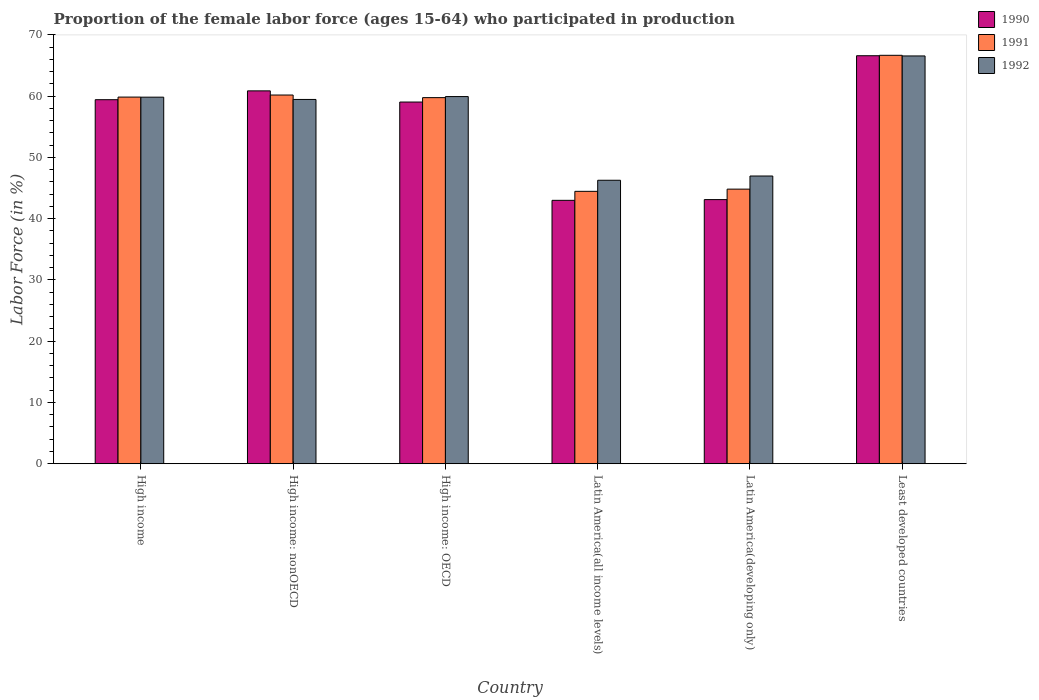How many different coloured bars are there?
Offer a very short reply. 3. How many groups of bars are there?
Give a very brief answer. 6. Are the number of bars per tick equal to the number of legend labels?
Ensure brevity in your answer.  Yes. Are the number of bars on each tick of the X-axis equal?
Your answer should be very brief. Yes. How many bars are there on the 1st tick from the left?
Ensure brevity in your answer.  3. How many bars are there on the 4th tick from the right?
Your answer should be very brief. 3. What is the label of the 5th group of bars from the left?
Keep it short and to the point. Latin America(developing only). What is the proportion of the female labor force who participated in production in 1991 in Least developed countries?
Keep it short and to the point. 66.68. Across all countries, what is the maximum proportion of the female labor force who participated in production in 1990?
Ensure brevity in your answer.  66.61. Across all countries, what is the minimum proportion of the female labor force who participated in production in 1990?
Your answer should be very brief. 43. In which country was the proportion of the female labor force who participated in production in 1990 maximum?
Ensure brevity in your answer.  Least developed countries. In which country was the proportion of the female labor force who participated in production in 1992 minimum?
Give a very brief answer. Latin America(all income levels). What is the total proportion of the female labor force who participated in production in 1991 in the graph?
Keep it short and to the point. 335.79. What is the difference between the proportion of the female labor force who participated in production in 1990 in High income and that in Latin America(all income levels)?
Ensure brevity in your answer.  16.43. What is the difference between the proportion of the female labor force who participated in production in 1990 in High income: OECD and the proportion of the female labor force who participated in production in 1992 in Least developed countries?
Offer a terse response. -7.52. What is the average proportion of the female labor force who participated in production in 1992 per country?
Give a very brief answer. 56.51. What is the difference between the proportion of the female labor force who participated in production of/in 1990 and proportion of the female labor force who participated in production of/in 1991 in Latin America(all income levels)?
Give a very brief answer. -1.47. In how many countries, is the proportion of the female labor force who participated in production in 1990 greater than 68 %?
Provide a succinct answer. 0. What is the ratio of the proportion of the female labor force who participated in production in 1992 in High income: nonOECD to that in Latin America(all income levels)?
Make the answer very short. 1.29. What is the difference between the highest and the second highest proportion of the female labor force who participated in production in 1991?
Keep it short and to the point. 6.82. What is the difference between the highest and the lowest proportion of the female labor force who participated in production in 1991?
Provide a succinct answer. 22.21. Is the sum of the proportion of the female labor force who participated in production in 1990 in High income: OECD and Least developed countries greater than the maximum proportion of the female labor force who participated in production in 1992 across all countries?
Your answer should be very brief. Yes. What does the 2nd bar from the right in High income: OECD represents?
Ensure brevity in your answer.  1991. Is it the case that in every country, the sum of the proportion of the female labor force who participated in production in 1990 and proportion of the female labor force who participated in production in 1991 is greater than the proportion of the female labor force who participated in production in 1992?
Provide a short and direct response. Yes. Are all the bars in the graph horizontal?
Provide a short and direct response. No. Does the graph contain grids?
Give a very brief answer. No. Where does the legend appear in the graph?
Provide a succinct answer. Top right. What is the title of the graph?
Offer a very short reply. Proportion of the female labor force (ages 15-64) who participated in production. Does "1996" appear as one of the legend labels in the graph?
Ensure brevity in your answer.  No. What is the label or title of the X-axis?
Offer a terse response. Country. What is the label or title of the Y-axis?
Provide a short and direct response. Labor Force (in %). What is the Labor Force (in %) in 1990 in High income?
Give a very brief answer. 59.43. What is the Labor Force (in %) in 1991 in High income?
Make the answer very short. 59.86. What is the Labor Force (in %) in 1992 in High income?
Your answer should be very brief. 59.84. What is the Labor Force (in %) in 1990 in High income: nonOECD?
Make the answer very short. 60.87. What is the Labor Force (in %) in 1991 in High income: nonOECD?
Your response must be concise. 60.19. What is the Labor Force (in %) of 1992 in High income: nonOECD?
Your answer should be compact. 59.47. What is the Labor Force (in %) of 1990 in High income: OECD?
Offer a terse response. 59.05. What is the Labor Force (in %) in 1991 in High income: OECD?
Provide a short and direct response. 59.77. What is the Labor Force (in %) in 1992 in High income: OECD?
Give a very brief answer. 59.94. What is the Labor Force (in %) of 1990 in Latin America(all income levels)?
Your answer should be compact. 43. What is the Labor Force (in %) of 1991 in Latin America(all income levels)?
Provide a short and direct response. 44.47. What is the Labor Force (in %) of 1992 in Latin America(all income levels)?
Keep it short and to the point. 46.28. What is the Labor Force (in %) of 1990 in Latin America(developing only)?
Ensure brevity in your answer.  43.12. What is the Labor Force (in %) in 1991 in Latin America(developing only)?
Provide a succinct answer. 44.83. What is the Labor Force (in %) of 1992 in Latin America(developing only)?
Provide a succinct answer. 46.97. What is the Labor Force (in %) of 1990 in Least developed countries?
Offer a very short reply. 66.61. What is the Labor Force (in %) in 1991 in Least developed countries?
Your answer should be very brief. 66.68. What is the Labor Force (in %) in 1992 in Least developed countries?
Provide a short and direct response. 66.57. Across all countries, what is the maximum Labor Force (in %) in 1990?
Make the answer very short. 66.61. Across all countries, what is the maximum Labor Force (in %) in 1991?
Give a very brief answer. 66.68. Across all countries, what is the maximum Labor Force (in %) of 1992?
Provide a short and direct response. 66.57. Across all countries, what is the minimum Labor Force (in %) of 1990?
Provide a succinct answer. 43. Across all countries, what is the minimum Labor Force (in %) of 1991?
Give a very brief answer. 44.47. Across all countries, what is the minimum Labor Force (in %) of 1992?
Provide a short and direct response. 46.28. What is the total Labor Force (in %) in 1990 in the graph?
Offer a terse response. 332.08. What is the total Labor Force (in %) in 1991 in the graph?
Your answer should be very brief. 335.79. What is the total Labor Force (in %) in 1992 in the graph?
Your answer should be very brief. 339.07. What is the difference between the Labor Force (in %) in 1990 in High income and that in High income: nonOECD?
Your response must be concise. -1.44. What is the difference between the Labor Force (in %) of 1991 in High income and that in High income: nonOECD?
Your answer should be compact. -0.34. What is the difference between the Labor Force (in %) in 1992 in High income and that in High income: nonOECD?
Keep it short and to the point. 0.37. What is the difference between the Labor Force (in %) in 1990 in High income and that in High income: OECD?
Your answer should be very brief. 0.38. What is the difference between the Labor Force (in %) of 1991 in High income and that in High income: OECD?
Your response must be concise. 0.09. What is the difference between the Labor Force (in %) in 1992 in High income and that in High income: OECD?
Make the answer very short. -0.1. What is the difference between the Labor Force (in %) in 1990 in High income and that in Latin America(all income levels)?
Ensure brevity in your answer.  16.43. What is the difference between the Labor Force (in %) of 1991 in High income and that in Latin America(all income levels)?
Offer a terse response. 15.39. What is the difference between the Labor Force (in %) in 1992 in High income and that in Latin America(all income levels)?
Your response must be concise. 13.56. What is the difference between the Labor Force (in %) in 1990 in High income and that in Latin America(developing only)?
Your answer should be compact. 16.31. What is the difference between the Labor Force (in %) in 1991 in High income and that in Latin America(developing only)?
Keep it short and to the point. 15.03. What is the difference between the Labor Force (in %) of 1992 in High income and that in Latin America(developing only)?
Your answer should be very brief. 12.87. What is the difference between the Labor Force (in %) of 1990 in High income and that in Least developed countries?
Offer a terse response. -7.18. What is the difference between the Labor Force (in %) of 1991 in High income and that in Least developed countries?
Provide a short and direct response. -6.82. What is the difference between the Labor Force (in %) in 1992 in High income and that in Least developed countries?
Keep it short and to the point. -6.73. What is the difference between the Labor Force (in %) in 1990 in High income: nonOECD and that in High income: OECD?
Provide a short and direct response. 1.82. What is the difference between the Labor Force (in %) of 1991 in High income: nonOECD and that in High income: OECD?
Offer a terse response. 0.43. What is the difference between the Labor Force (in %) of 1992 in High income: nonOECD and that in High income: OECD?
Provide a short and direct response. -0.47. What is the difference between the Labor Force (in %) of 1990 in High income: nonOECD and that in Latin America(all income levels)?
Your response must be concise. 17.87. What is the difference between the Labor Force (in %) of 1991 in High income: nonOECD and that in Latin America(all income levels)?
Provide a short and direct response. 15.72. What is the difference between the Labor Force (in %) in 1992 in High income: nonOECD and that in Latin America(all income levels)?
Your answer should be compact. 13.19. What is the difference between the Labor Force (in %) of 1990 in High income: nonOECD and that in Latin America(developing only)?
Your response must be concise. 17.75. What is the difference between the Labor Force (in %) in 1991 in High income: nonOECD and that in Latin America(developing only)?
Your answer should be compact. 15.36. What is the difference between the Labor Force (in %) of 1992 in High income: nonOECD and that in Latin America(developing only)?
Ensure brevity in your answer.  12.5. What is the difference between the Labor Force (in %) in 1990 in High income: nonOECD and that in Least developed countries?
Keep it short and to the point. -5.74. What is the difference between the Labor Force (in %) in 1991 in High income: nonOECD and that in Least developed countries?
Your response must be concise. -6.48. What is the difference between the Labor Force (in %) of 1992 in High income: nonOECD and that in Least developed countries?
Provide a succinct answer. -7.1. What is the difference between the Labor Force (in %) in 1990 in High income: OECD and that in Latin America(all income levels)?
Offer a terse response. 16.05. What is the difference between the Labor Force (in %) of 1991 in High income: OECD and that in Latin America(all income levels)?
Make the answer very short. 15.3. What is the difference between the Labor Force (in %) of 1992 in High income: OECD and that in Latin America(all income levels)?
Your response must be concise. 13.66. What is the difference between the Labor Force (in %) of 1990 in High income: OECD and that in Latin America(developing only)?
Keep it short and to the point. 15.93. What is the difference between the Labor Force (in %) in 1991 in High income: OECD and that in Latin America(developing only)?
Provide a succinct answer. 14.94. What is the difference between the Labor Force (in %) of 1992 in High income: OECD and that in Latin America(developing only)?
Give a very brief answer. 12.97. What is the difference between the Labor Force (in %) in 1990 in High income: OECD and that in Least developed countries?
Ensure brevity in your answer.  -7.56. What is the difference between the Labor Force (in %) of 1991 in High income: OECD and that in Least developed countries?
Ensure brevity in your answer.  -6.91. What is the difference between the Labor Force (in %) in 1992 in High income: OECD and that in Least developed countries?
Provide a succinct answer. -6.63. What is the difference between the Labor Force (in %) in 1990 in Latin America(all income levels) and that in Latin America(developing only)?
Provide a short and direct response. -0.12. What is the difference between the Labor Force (in %) in 1991 in Latin America(all income levels) and that in Latin America(developing only)?
Your answer should be compact. -0.36. What is the difference between the Labor Force (in %) of 1992 in Latin America(all income levels) and that in Latin America(developing only)?
Your answer should be compact. -0.69. What is the difference between the Labor Force (in %) of 1990 in Latin America(all income levels) and that in Least developed countries?
Your answer should be compact. -23.61. What is the difference between the Labor Force (in %) of 1991 in Latin America(all income levels) and that in Least developed countries?
Provide a succinct answer. -22.21. What is the difference between the Labor Force (in %) of 1992 in Latin America(all income levels) and that in Least developed countries?
Ensure brevity in your answer.  -20.29. What is the difference between the Labor Force (in %) in 1990 in Latin America(developing only) and that in Least developed countries?
Offer a very short reply. -23.49. What is the difference between the Labor Force (in %) of 1991 in Latin America(developing only) and that in Least developed countries?
Keep it short and to the point. -21.85. What is the difference between the Labor Force (in %) in 1992 in Latin America(developing only) and that in Least developed countries?
Your response must be concise. -19.6. What is the difference between the Labor Force (in %) in 1990 in High income and the Labor Force (in %) in 1991 in High income: nonOECD?
Offer a very short reply. -0.76. What is the difference between the Labor Force (in %) of 1990 in High income and the Labor Force (in %) of 1992 in High income: nonOECD?
Offer a terse response. -0.04. What is the difference between the Labor Force (in %) in 1991 in High income and the Labor Force (in %) in 1992 in High income: nonOECD?
Provide a succinct answer. 0.38. What is the difference between the Labor Force (in %) in 1990 in High income and the Labor Force (in %) in 1991 in High income: OECD?
Provide a succinct answer. -0.34. What is the difference between the Labor Force (in %) of 1990 in High income and the Labor Force (in %) of 1992 in High income: OECD?
Ensure brevity in your answer.  -0.51. What is the difference between the Labor Force (in %) in 1991 in High income and the Labor Force (in %) in 1992 in High income: OECD?
Offer a terse response. -0.08. What is the difference between the Labor Force (in %) in 1990 in High income and the Labor Force (in %) in 1991 in Latin America(all income levels)?
Provide a short and direct response. 14.96. What is the difference between the Labor Force (in %) of 1990 in High income and the Labor Force (in %) of 1992 in Latin America(all income levels)?
Your answer should be very brief. 13.15. What is the difference between the Labor Force (in %) of 1991 in High income and the Labor Force (in %) of 1992 in Latin America(all income levels)?
Provide a short and direct response. 13.58. What is the difference between the Labor Force (in %) of 1990 in High income and the Labor Force (in %) of 1991 in Latin America(developing only)?
Offer a very short reply. 14.6. What is the difference between the Labor Force (in %) in 1990 in High income and the Labor Force (in %) in 1992 in Latin America(developing only)?
Provide a short and direct response. 12.46. What is the difference between the Labor Force (in %) of 1991 in High income and the Labor Force (in %) of 1992 in Latin America(developing only)?
Your answer should be very brief. 12.88. What is the difference between the Labor Force (in %) of 1990 in High income and the Labor Force (in %) of 1991 in Least developed countries?
Offer a terse response. -7.25. What is the difference between the Labor Force (in %) in 1990 in High income and the Labor Force (in %) in 1992 in Least developed countries?
Offer a very short reply. -7.14. What is the difference between the Labor Force (in %) of 1991 in High income and the Labor Force (in %) of 1992 in Least developed countries?
Ensure brevity in your answer.  -6.72. What is the difference between the Labor Force (in %) of 1990 in High income: nonOECD and the Labor Force (in %) of 1991 in High income: OECD?
Provide a short and direct response. 1.11. What is the difference between the Labor Force (in %) in 1990 in High income: nonOECD and the Labor Force (in %) in 1992 in High income: OECD?
Give a very brief answer. 0.93. What is the difference between the Labor Force (in %) in 1991 in High income: nonOECD and the Labor Force (in %) in 1992 in High income: OECD?
Keep it short and to the point. 0.25. What is the difference between the Labor Force (in %) of 1990 in High income: nonOECD and the Labor Force (in %) of 1991 in Latin America(all income levels)?
Ensure brevity in your answer.  16.4. What is the difference between the Labor Force (in %) of 1990 in High income: nonOECD and the Labor Force (in %) of 1992 in Latin America(all income levels)?
Your response must be concise. 14.59. What is the difference between the Labor Force (in %) in 1991 in High income: nonOECD and the Labor Force (in %) in 1992 in Latin America(all income levels)?
Your answer should be very brief. 13.92. What is the difference between the Labor Force (in %) in 1990 in High income: nonOECD and the Labor Force (in %) in 1991 in Latin America(developing only)?
Offer a very short reply. 16.04. What is the difference between the Labor Force (in %) in 1990 in High income: nonOECD and the Labor Force (in %) in 1992 in Latin America(developing only)?
Provide a short and direct response. 13.9. What is the difference between the Labor Force (in %) in 1991 in High income: nonOECD and the Labor Force (in %) in 1992 in Latin America(developing only)?
Make the answer very short. 13.22. What is the difference between the Labor Force (in %) in 1990 in High income: nonOECD and the Labor Force (in %) in 1991 in Least developed countries?
Provide a short and direct response. -5.81. What is the difference between the Labor Force (in %) of 1990 in High income: nonOECD and the Labor Force (in %) of 1992 in Least developed countries?
Provide a succinct answer. -5.7. What is the difference between the Labor Force (in %) in 1991 in High income: nonOECD and the Labor Force (in %) in 1992 in Least developed countries?
Keep it short and to the point. -6.38. What is the difference between the Labor Force (in %) of 1990 in High income: OECD and the Labor Force (in %) of 1991 in Latin America(all income levels)?
Offer a very short reply. 14.58. What is the difference between the Labor Force (in %) of 1990 in High income: OECD and the Labor Force (in %) of 1992 in Latin America(all income levels)?
Give a very brief answer. 12.77. What is the difference between the Labor Force (in %) of 1991 in High income: OECD and the Labor Force (in %) of 1992 in Latin America(all income levels)?
Offer a very short reply. 13.49. What is the difference between the Labor Force (in %) of 1990 in High income: OECD and the Labor Force (in %) of 1991 in Latin America(developing only)?
Offer a very short reply. 14.22. What is the difference between the Labor Force (in %) in 1990 in High income: OECD and the Labor Force (in %) in 1992 in Latin America(developing only)?
Provide a short and direct response. 12.08. What is the difference between the Labor Force (in %) of 1991 in High income: OECD and the Labor Force (in %) of 1992 in Latin America(developing only)?
Give a very brief answer. 12.79. What is the difference between the Labor Force (in %) in 1990 in High income: OECD and the Labor Force (in %) in 1991 in Least developed countries?
Give a very brief answer. -7.63. What is the difference between the Labor Force (in %) of 1990 in High income: OECD and the Labor Force (in %) of 1992 in Least developed countries?
Provide a succinct answer. -7.52. What is the difference between the Labor Force (in %) in 1991 in High income: OECD and the Labor Force (in %) in 1992 in Least developed countries?
Make the answer very short. -6.81. What is the difference between the Labor Force (in %) of 1990 in Latin America(all income levels) and the Labor Force (in %) of 1991 in Latin America(developing only)?
Offer a very short reply. -1.83. What is the difference between the Labor Force (in %) in 1990 in Latin America(all income levels) and the Labor Force (in %) in 1992 in Latin America(developing only)?
Offer a terse response. -3.97. What is the difference between the Labor Force (in %) of 1991 in Latin America(all income levels) and the Labor Force (in %) of 1992 in Latin America(developing only)?
Offer a very short reply. -2.5. What is the difference between the Labor Force (in %) in 1990 in Latin America(all income levels) and the Labor Force (in %) in 1991 in Least developed countries?
Offer a very short reply. -23.68. What is the difference between the Labor Force (in %) of 1990 in Latin America(all income levels) and the Labor Force (in %) of 1992 in Least developed countries?
Provide a short and direct response. -23.57. What is the difference between the Labor Force (in %) of 1991 in Latin America(all income levels) and the Labor Force (in %) of 1992 in Least developed countries?
Your answer should be very brief. -22.1. What is the difference between the Labor Force (in %) of 1990 in Latin America(developing only) and the Labor Force (in %) of 1991 in Least developed countries?
Give a very brief answer. -23.56. What is the difference between the Labor Force (in %) of 1990 in Latin America(developing only) and the Labor Force (in %) of 1992 in Least developed countries?
Ensure brevity in your answer.  -23.45. What is the difference between the Labor Force (in %) in 1991 in Latin America(developing only) and the Labor Force (in %) in 1992 in Least developed countries?
Offer a terse response. -21.74. What is the average Labor Force (in %) of 1990 per country?
Your answer should be compact. 55.35. What is the average Labor Force (in %) in 1991 per country?
Give a very brief answer. 55.97. What is the average Labor Force (in %) in 1992 per country?
Your response must be concise. 56.51. What is the difference between the Labor Force (in %) of 1990 and Labor Force (in %) of 1991 in High income?
Provide a short and direct response. -0.43. What is the difference between the Labor Force (in %) of 1990 and Labor Force (in %) of 1992 in High income?
Your answer should be compact. -0.41. What is the difference between the Labor Force (in %) in 1991 and Labor Force (in %) in 1992 in High income?
Provide a succinct answer. 0.01. What is the difference between the Labor Force (in %) of 1990 and Labor Force (in %) of 1991 in High income: nonOECD?
Your answer should be compact. 0.68. What is the difference between the Labor Force (in %) in 1990 and Labor Force (in %) in 1992 in High income: nonOECD?
Offer a terse response. 1.4. What is the difference between the Labor Force (in %) of 1991 and Labor Force (in %) of 1992 in High income: nonOECD?
Offer a terse response. 0.72. What is the difference between the Labor Force (in %) of 1990 and Labor Force (in %) of 1991 in High income: OECD?
Your answer should be very brief. -0.72. What is the difference between the Labor Force (in %) of 1990 and Labor Force (in %) of 1992 in High income: OECD?
Keep it short and to the point. -0.89. What is the difference between the Labor Force (in %) of 1991 and Labor Force (in %) of 1992 in High income: OECD?
Keep it short and to the point. -0.17. What is the difference between the Labor Force (in %) in 1990 and Labor Force (in %) in 1991 in Latin America(all income levels)?
Offer a very short reply. -1.47. What is the difference between the Labor Force (in %) in 1990 and Labor Force (in %) in 1992 in Latin America(all income levels)?
Ensure brevity in your answer.  -3.28. What is the difference between the Labor Force (in %) of 1991 and Labor Force (in %) of 1992 in Latin America(all income levels)?
Offer a terse response. -1.81. What is the difference between the Labor Force (in %) in 1990 and Labor Force (in %) in 1991 in Latin America(developing only)?
Your answer should be very brief. -1.71. What is the difference between the Labor Force (in %) in 1990 and Labor Force (in %) in 1992 in Latin America(developing only)?
Offer a terse response. -3.85. What is the difference between the Labor Force (in %) of 1991 and Labor Force (in %) of 1992 in Latin America(developing only)?
Your answer should be very brief. -2.14. What is the difference between the Labor Force (in %) of 1990 and Labor Force (in %) of 1991 in Least developed countries?
Give a very brief answer. -0.07. What is the difference between the Labor Force (in %) of 1990 and Labor Force (in %) of 1992 in Least developed countries?
Your answer should be compact. 0.03. What is the difference between the Labor Force (in %) of 1991 and Labor Force (in %) of 1992 in Least developed countries?
Provide a short and direct response. 0.1. What is the ratio of the Labor Force (in %) in 1990 in High income to that in High income: nonOECD?
Offer a terse response. 0.98. What is the ratio of the Labor Force (in %) of 1992 in High income to that in High income: nonOECD?
Provide a short and direct response. 1.01. What is the ratio of the Labor Force (in %) of 1991 in High income to that in High income: OECD?
Offer a terse response. 1. What is the ratio of the Labor Force (in %) of 1990 in High income to that in Latin America(all income levels)?
Your answer should be very brief. 1.38. What is the ratio of the Labor Force (in %) in 1991 in High income to that in Latin America(all income levels)?
Offer a very short reply. 1.35. What is the ratio of the Labor Force (in %) in 1992 in High income to that in Latin America(all income levels)?
Give a very brief answer. 1.29. What is the ratio of the Labor Force (in %) of 1990 in High income to that in Latin America(developing only)?
Keep it short and to the point. 1.38. What is the ratio of the Labor Force (in %) in 1991 in High income to that in Latin America(developing only)?
Provide a short and direct response. 1.34. What is the ratio of the Labor Force (in %) of 1992 in High income to that in Latin America(developing only)?
Give a very brief answer. 1.27. What is the ratio of the Labor Force (in %) in 1990 in High income to that in Least developed countries?
Your answer should be compact. 0.89. What is the ratio of the Labor Force (in %) in 1991 in High income to that in Least developed countries?
Give a very brief answer. 0.9. What is the ratio of the Labor Force (in %) in 1992 in High income to that in Least developed countries?
Provide a short and direct response. 0.9. What is the ratio of the Labor Force (in %) of 1990 in High income: nonOECD to that in High income: OECD?
Make the answer very short. 1.03. What is the ratio of the Labor Force (in %) of 1991 in High income: nonOECD to that in High income: OECD?
Offer a very short reply. 1.01. What is the ratio of the Labor Force (in %) in 1992 in High income: nonOECD to that in High income: OECD?
Give a very brief answer. 0.99. What is the ratio of the Labor Force (in %) in 1990 in High income: nonOECD to that in Latin America(all income levels)?
Make the answer very short. 1.42. What is the ratio of the Labor Force (in %) in 1991 in High income: nonOECD to that in Latin America(all income levels)?
Offer a terse response. 1.35. What is the ratio of the Labor Force (in %) of 1992 in High income: nonOECD to that in Latin America(all income levels)?
Your answer should be very brief. 1.29. What is the ratio of the Labor Force (in %) in 1990 in High income: nonOECD to that in Latin America(developing only)?
Ensure brevity in your answer.  1.41. What is the ratio of the Labor Force (in %) of 1991 in High income: nonOECD to that in Latin America(developing only)?
Give a very brief answer. 1.34. What is the ratio of the Labor Force (in %) in 1992 in High income: nonOECD to that in Latin America(developing only)?
Ensure brevity in your answer.  1.27. What is the ratio of the Labor Force (in %) of 1990 in High income: nonOECD to that in Least developed countries?
Make the answer very short. 0.91. What is the ratio of the Labor Force (in %) of 1991 in High income: nonOECD to that in Least developed countries?
Your response must be concise. 0.9. What is the ratio of the Labor Force (in %) of 1992 in High income: nonOECD to that in Least developed countries?
Your answer should be very brief. 0.89. What is the ratio of the Labor Force (in %) of 1990 in High income: OECD to that in Latin America(all income levels)?
Your answer should be very brief. 1.37. What is the ratio of the Labor Force (in %) of 1991 in High income: OECD to that in Latin America(all income levels)?
Offer a terse response. 1.34. What is the ratio of the Labor Force (in %) of 1992 in High income: OECD to that in Latin America(all income levels)?
Offer a terse response. 1.3. What is the ratio of the Labor Force (in %) of 1990 in High income: OECD to that in Latin America(developing only)?
Your answer should be compact. 1.37. What is the ratio of the Labor Force (in %) in 1991 in High income: OECD to that in Latin America(developing only)?
Ensure brevity in your answer.  1.33. What is the ratio of the Labor Force (in %) of 1992 in High income: OECD to that in Latin America(developing only)?
Ensure brevity in your answer.  1.28. What is the ratio of the Labor Force (in %) of 1990 in High income: OECD to that in Least developed countries?
Your answer should be compact. 0.89. What is the ratio of the Labor Force (in %) in 1991 in High income: OECD to that in Least developed countries?
Provide a succinct answer. 0.9. What is the ratio of the Labor Force (in %) of 1992 in High income: OECD to that in Least developed countries?
Offer a very short reply. 0.9. What is the ratio of the Labor Force (in %) in 1990 in Latin America(all income levels) to that in Latin America(developing only)?
Your answer should be compact. 1. What is the ratio of the Labor Force (in %) in 1992 in Latin America(all income levels) to that in Latin America(developing only)?
Provide a succinct answer. 0.99. What is the ratio of the Labor Force (in %) in 1990 in Latin America(all income levels) to that in Least developed countries?
Your answer should be compact. 0.65. What is the ratio of the Labor Force (in %) in 1991 in Latin America(all income levels) to that in Least developed countries?
Offer a very short reply. 0.67. What is the ratio of the Labor Force (in %) of 1992 in Latin America(all income levels) to that in Least developed countries?
Offer a terse response. 0.7. What is the ratio of the Labor Force (in %) of 1990 in Latin America(developing only) to that in Least developed countries?
Give a very brief answer. 0.65. What is the ratio of the Labor Force (in %) in 1991 in Latin America(developing only) to that in Least developed countries?
Your response must be concise. 0.67. What is the ratio of the Labor Force (in %) of 1992 in Latin America(developing only) to that in Least developed countries?
Your answer should be compact. 0.71. What is the difference between the highest and the second highest Labor Force (in %) in 1990?
Your answer should be compact. 5.74. What is the difference between the highest and the second highest Labor Force (in %) of 1991?
Your answer should be compact. 6.48. What is the difference between the highest and the second highest Labor Force (in %) of 1992?
Your answer should be very brief. 6.63. What is the difference between the highest and the lowest Labor Force (in %) of 1990?
Your response must be concise. 23.61. What is the difference between the highest and the lowest Labor Force (in %) in 1991?
Provide a short and direct response. 22.21. What is the difference between the highest and the lowest Labor Force (in %) in 1992?
Your answer should be compact. 20.29. 